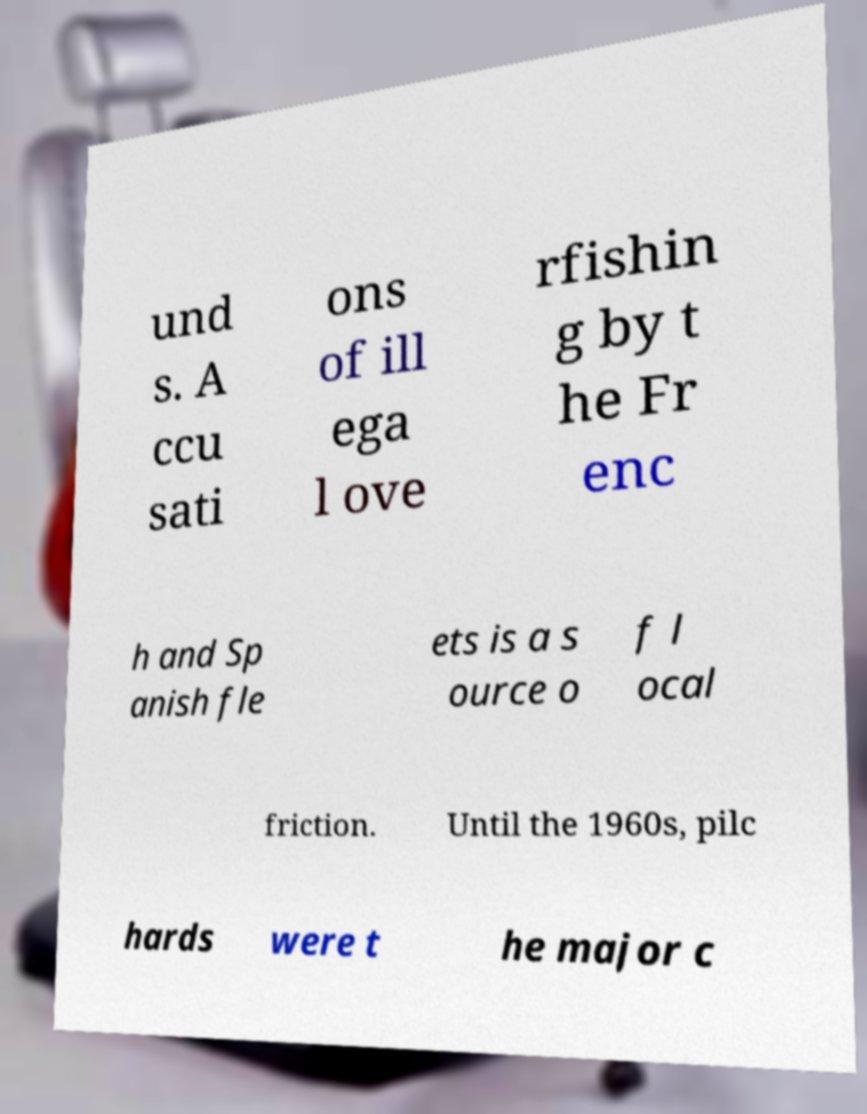Can you read and provide the text displayed in the image?This photo seems to have some interesting text. Can you extract and type it out for me? und s. A ccu sati ons of ill ega l ove rfishin g by t he Fr enc h and Sp anish fle ets is a s ource o f l ocal friction. Until the 1960s, pilc hards were t he major c 